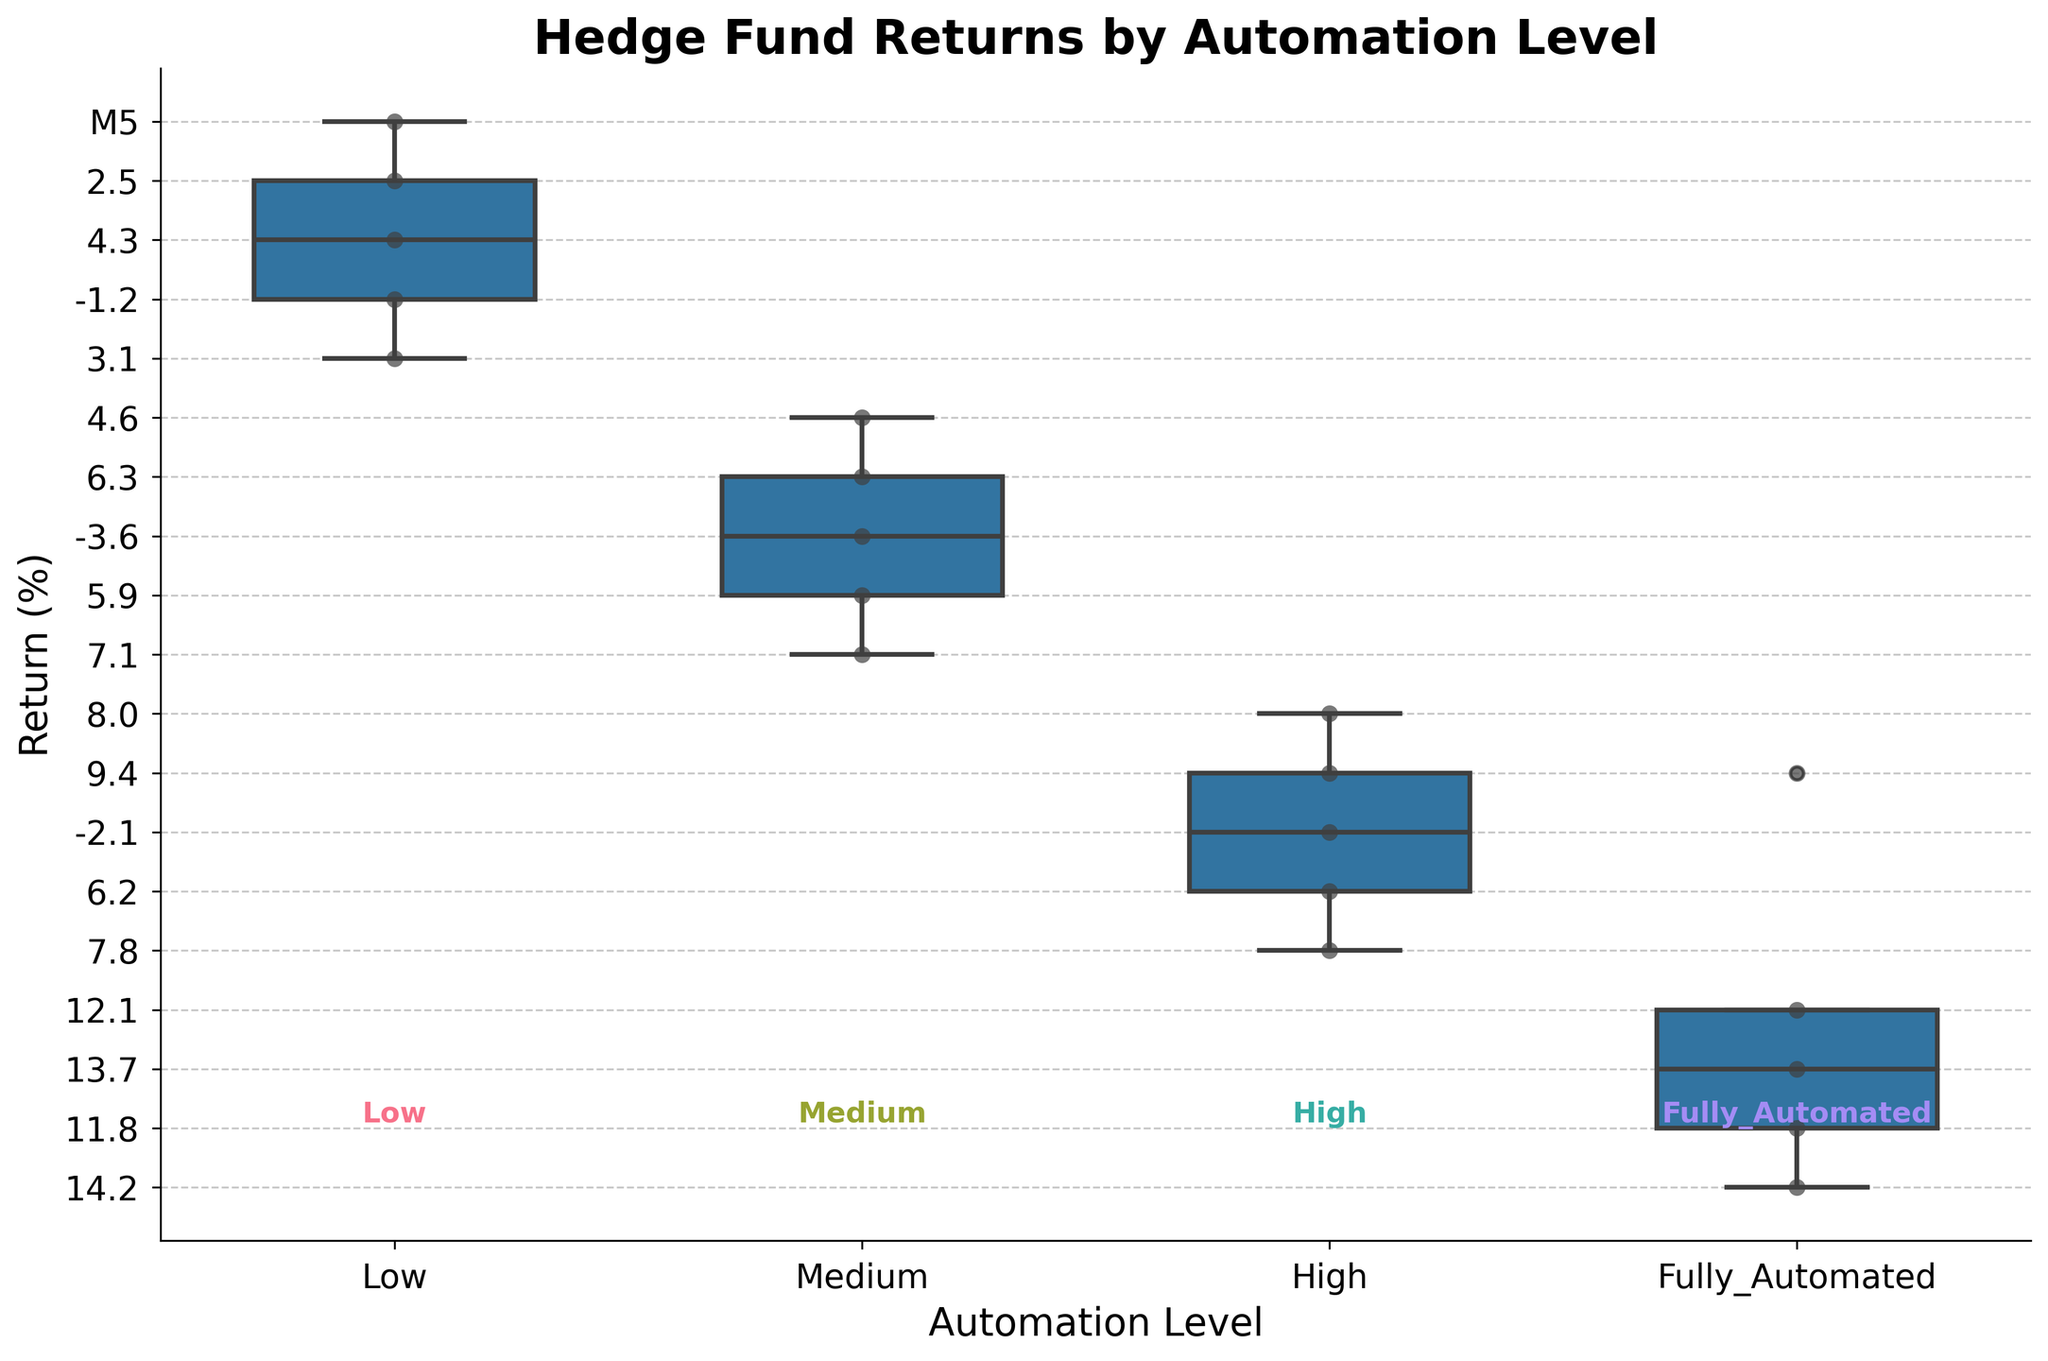what's the title of the figure? The title of the figure is displayed at the top and it typically provides a summary of what the figure is showing. In this case, the title reads "Hedge Fund Returns by Automation Level".
Answer: Hedge Fund Returns by Automation Level How many automation levels are depicted in the figure? To determine the number of automation levels, count the distinct categories on the x-axis. These categories are labeled as Low, Medium, High, and Fully_Automated.
Answer: 4 Which automation level shows the highest median return? To find the highest median return, compare the bold horizontal lines within each box. The highest median line is located in the Fully_Automated category.
Answer: Fully_Automated What is the range of returns for the hedge funds in the Medium automation level? The range is determined by finding the difference between the maximum and minimum values represented by the whiskers in the box plot for the Medium automation level. The maximum and minimum whiskers are at 7.1 and -3.6 respectively, giving a range of 7.1 - (-3.6) = 10.7.
Answer: 10.7 Which fund has the most concentrated (least spread out) returns, and why? The concentration of returns can be assessed by looking at the interquartile range (IQR), which is the length of the box. The High automation level box appears to be the narrowest, indicating the most concentrated returns.
Answer: High Compare the median return of Medium automation to Low automation. To compare the medians, look at the bold horizontal lines within each box. The median return for Medium is higher than for Low.
Answer: Medium is higher In which automation level do the returns show the most variability? Variability can be judged by the total spread of the data points (the length of the whiskers plus any outliers). The Medium automation level shows the most variability as its whiskers and outliers span the largest range.
Answer: Medium Which automation level has the highest maximum return? The highest maximum return can be seen at the top whisker or outlier point of the box plot. This is observed in the Fully_Automated category.
Answer: Fully_Automated Are there any negative returns in the Fully_Automated category? We can determine this by observing the positions of the data points and whiskers. In the Fully_Automated category, all data points are above zero, indicating no negative returns.
Answer: No 